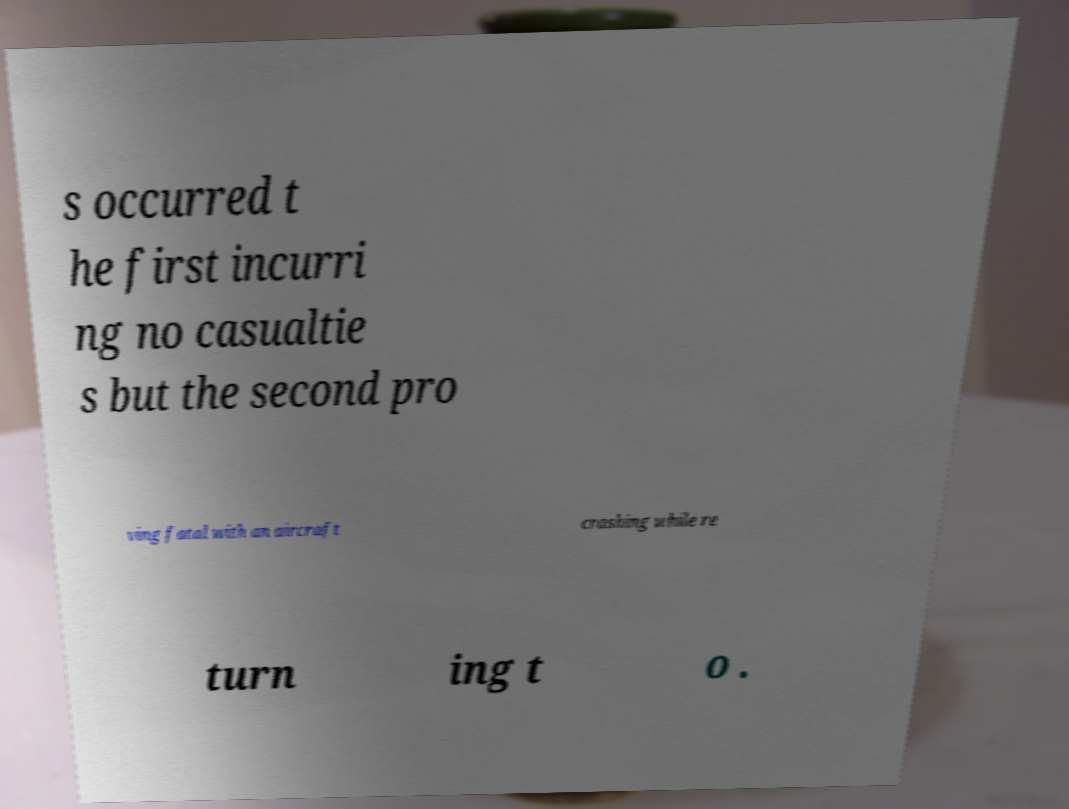Can you accurately transcribe the text from the provided image for me? s occurred t he first incurri ng no casualtie s but the second pro ving fatal with an aircraft crashing while re turn ing t o . 